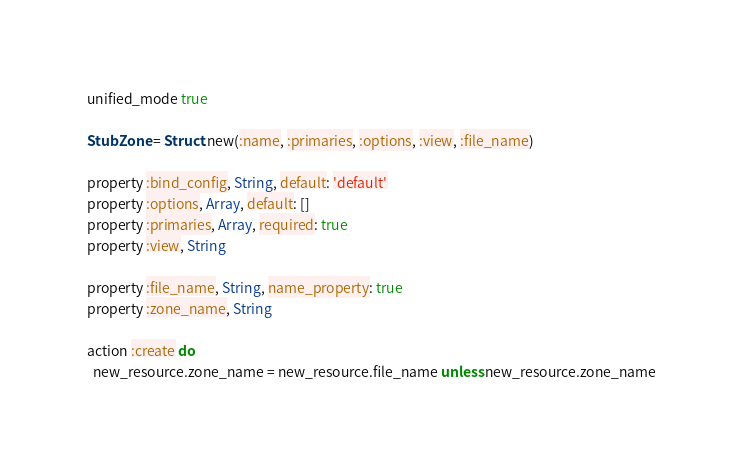<code> <loc_0><loc_0><loc_500><loc_500><_Ruby_>unified_mode true

StubZone = Struct.new(:name, :primaries, :options, :view, :file_name)

property :bind_config, String, default: 'default'
property :options, Array, default: []
property :primaries, Array, required: true
property :view, String

property :file_name, String, name_property: true
property :zone_name, String

action :create do
  new_resource.zone_name = new_resource.file_name unless new_resource.zone_name
</code> 